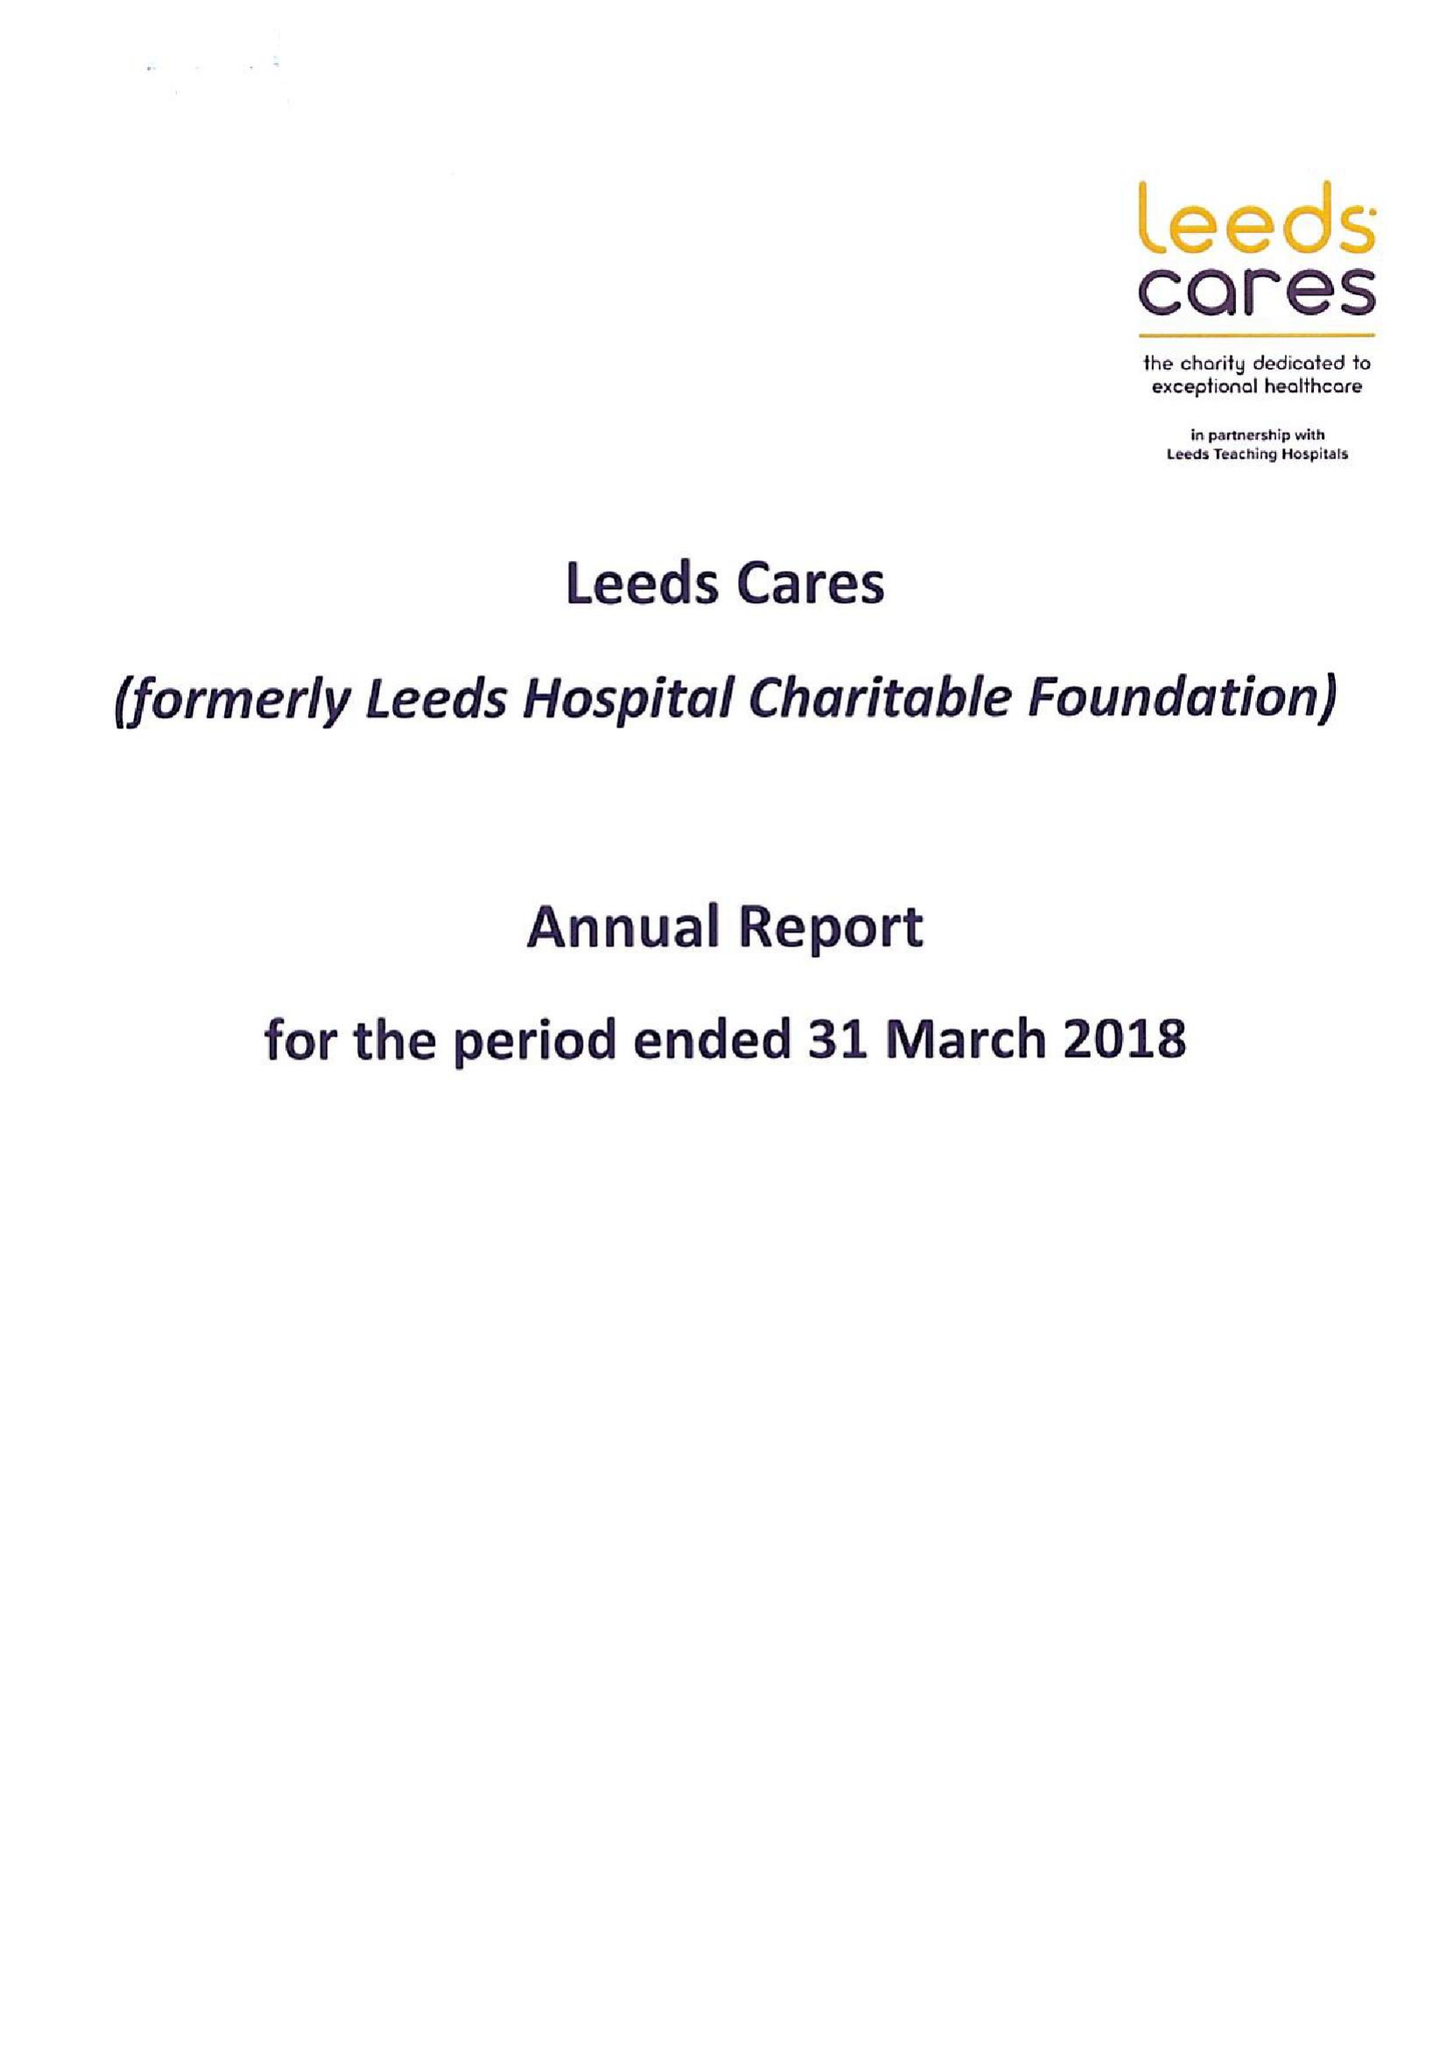What is the value for the address__postcode?
Answer the question using a single word or phrase. LS9 7TF 